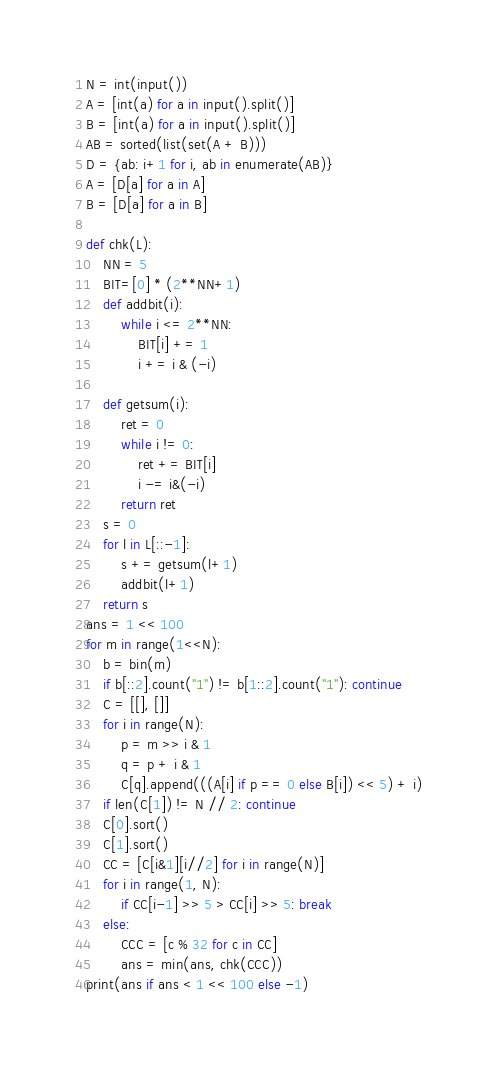<code> <loc_0><loc_0><loc_500><loc_500><_Python_>N = int(input())
A = [int(a) for a in input().split()]
B = [int(a) for a in input().split()]
AB = sorted(list(set(A + B)))
D = {ab: i+1 for i, ab in enumerate(AB)}
A = [D[a] for a in A]
B = [D[a] for a in B]

def chk(L):
    NN = 5
    BIT=[0] * (2**NN+1)
    def addbit(i):
        while i <= 2**NN:
            BIT[i] += 1
            i += i & (-i)
 
    def getsum(i):
        ret = 0
        while i != 0:
            ret += BIT[i]
            i -= i&(-i)
        return ret
    s = 0
    for l in L[::-1]:
        s += getsum(l+1)
        addbit(l+1)
    return s
ans = 1 << 100
for m in range(1<<N):
    b = bin(m)
    if b[::2].count("1") != b[1::2].count("1"): continue
    C = [[], []]
    for i in range(N):
        p = m >> i & 1
        q = p + i & 1
        C[q].append(((A[i] if p == 0 else B[i]) << 5) + i)
    if len(C[1]) != N // 2: continue
    C[0].sort()
    C[1].sort()
    CC = [C[i&1][i//2] for i in range(N)]
    for i in range(1, N):
        if CC[i-1] >> 5 > CC[i] >> 5: break
    else:
        CCC = [c % 32 for c in CC]
        ans = min(ans, chk(CCC))
print(ans if ans < 1 << 100 else -1)</code> 